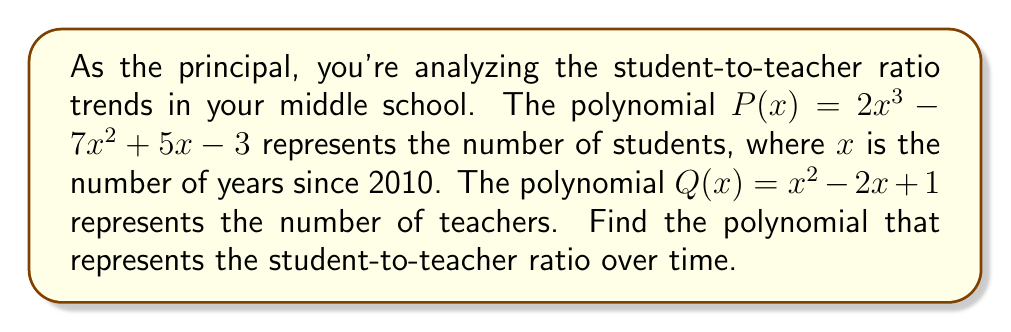Help me with this question. To find the student-to-teacher ratio, we need to divide $P(x)$ by $Q(x)$. Let's perform polynomial long division:

$$\frac{P(x)}{Q(x)} = \frac{2x^3 - 7x^2 + 5x - 3}{x^2 - 2x + 1}$$

Step 1: Divide $2x^3$ by $x^2$. This gives $2x$.
$$2x(x^2 - 2x + 1) = 2x^3 - 4x^2 + 2x$$

Step 2: Subtract from $P(x)$:
$$(2x^3 - 7x^2 + 5x - 3) - (2x^3 - 4x^2 + 2x) = -3x^2 + 3x - 3$$

Step 3: Bring down the remainder and repeat the process:
$$\frac{-3x^2 + 3x - 3}{x^2 - 2x + 1}$$

Divide $-3x^2$ by $x^2$. This gives $-3$.
$$-3(x^2 - 2x + 1) = -3x^2 + 6x - 3$$

Step 4: Subtract:
$$(-3x^2 + 3x - 3) - (-3x^2 + 6x - 3) = -3x$$

Step 5: Bring down the remainder and repeat:
$$\frac{-3x}{x^2 - 2x + 1}$$

The division process ends here as the degree of $-3x$ is less than the degree of $x^2 - 2x + 1$.

Therefore, the result of the division is:

$$2x - 3 + \frac{-3x}{x^2 - 2x + 1}$$

This polynomial represents the student-to-teacher ratio over time.
Answer: $2x - 3 + \frac{-3x}{x^2 - 2x + 1}$ 